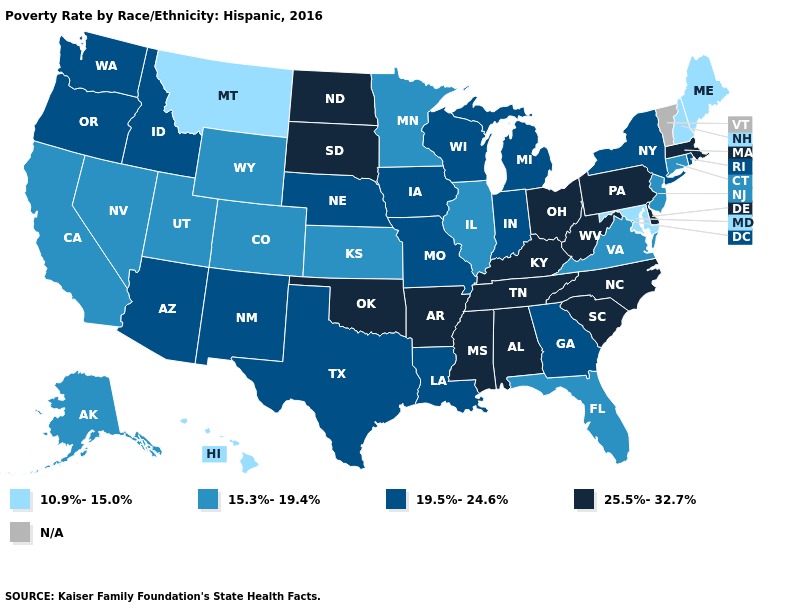Name the states that have a value in the range N/A?
Quick response, please. Vermont. What is the lowest value in the USA?
Concise answer only. 10.9%-15.0%. What is the highest value in the USA?
Concise answer only. 25.5%-32.7%. How many symbols are there in the legend?
Short answer required. 5. Which states have the highest value in the USA?
Write a very short answer. Alabama, Arkansas, Delaware, Kentucky, Massachusetts, Mississippi, North Carolina, North Dakota, Ohio, Oklahoma, Pennsylvania, South Carolina, South Dakota, Tennessee, West Virginia. Does the first symbol in the legend represent the smallest category?
Be succinct. Yes. What is the lowest value in the USA?
Keep it brief. 10.9%-15.0%. Is the legend a continuous bar?
Give a very brief answer. No. Does the first symbol in the legend represent the smallest category?
Concise answer only. Yes. What is the value of Georgia?
Concise answer only. 19.5%-24.6%. Does Maryland have the lowest value in the USA?
Write a very short answer. Yes. Name the states that have a value in the range 10.9%-15.0%?
Write a very short answer. Hawaii, Maine, Maryland, Montana, New Hampshire. Which states have the highest value in the USA?
Concise answer only. Alabama, Arkansas, Delaware, Kentucky, Massachusetts, Mississippi, North Carolina, North Dakota, Ohio, Oklahoma, Pennsylvania, South Carolina, South Dakota, Tennessee, West Virginia. What is the highest value in states that border Vermont?
Answer briefly. 25.5%-32.7%. Among the states that border Michigan , does Ohio have the lowest value?
Short answer required. No. 